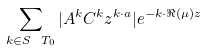Convert formula to latex. <formula><loc_0><loc_0><loc_500><loc_500>\sum _ { k \in S \ T _ { 0 } } | { A ^ { k } } { C } ^ { k } z ^ { { k } \cdot { a } } | e ^ { - { k } \cdot \Re ( \mu ) z }</formula> 